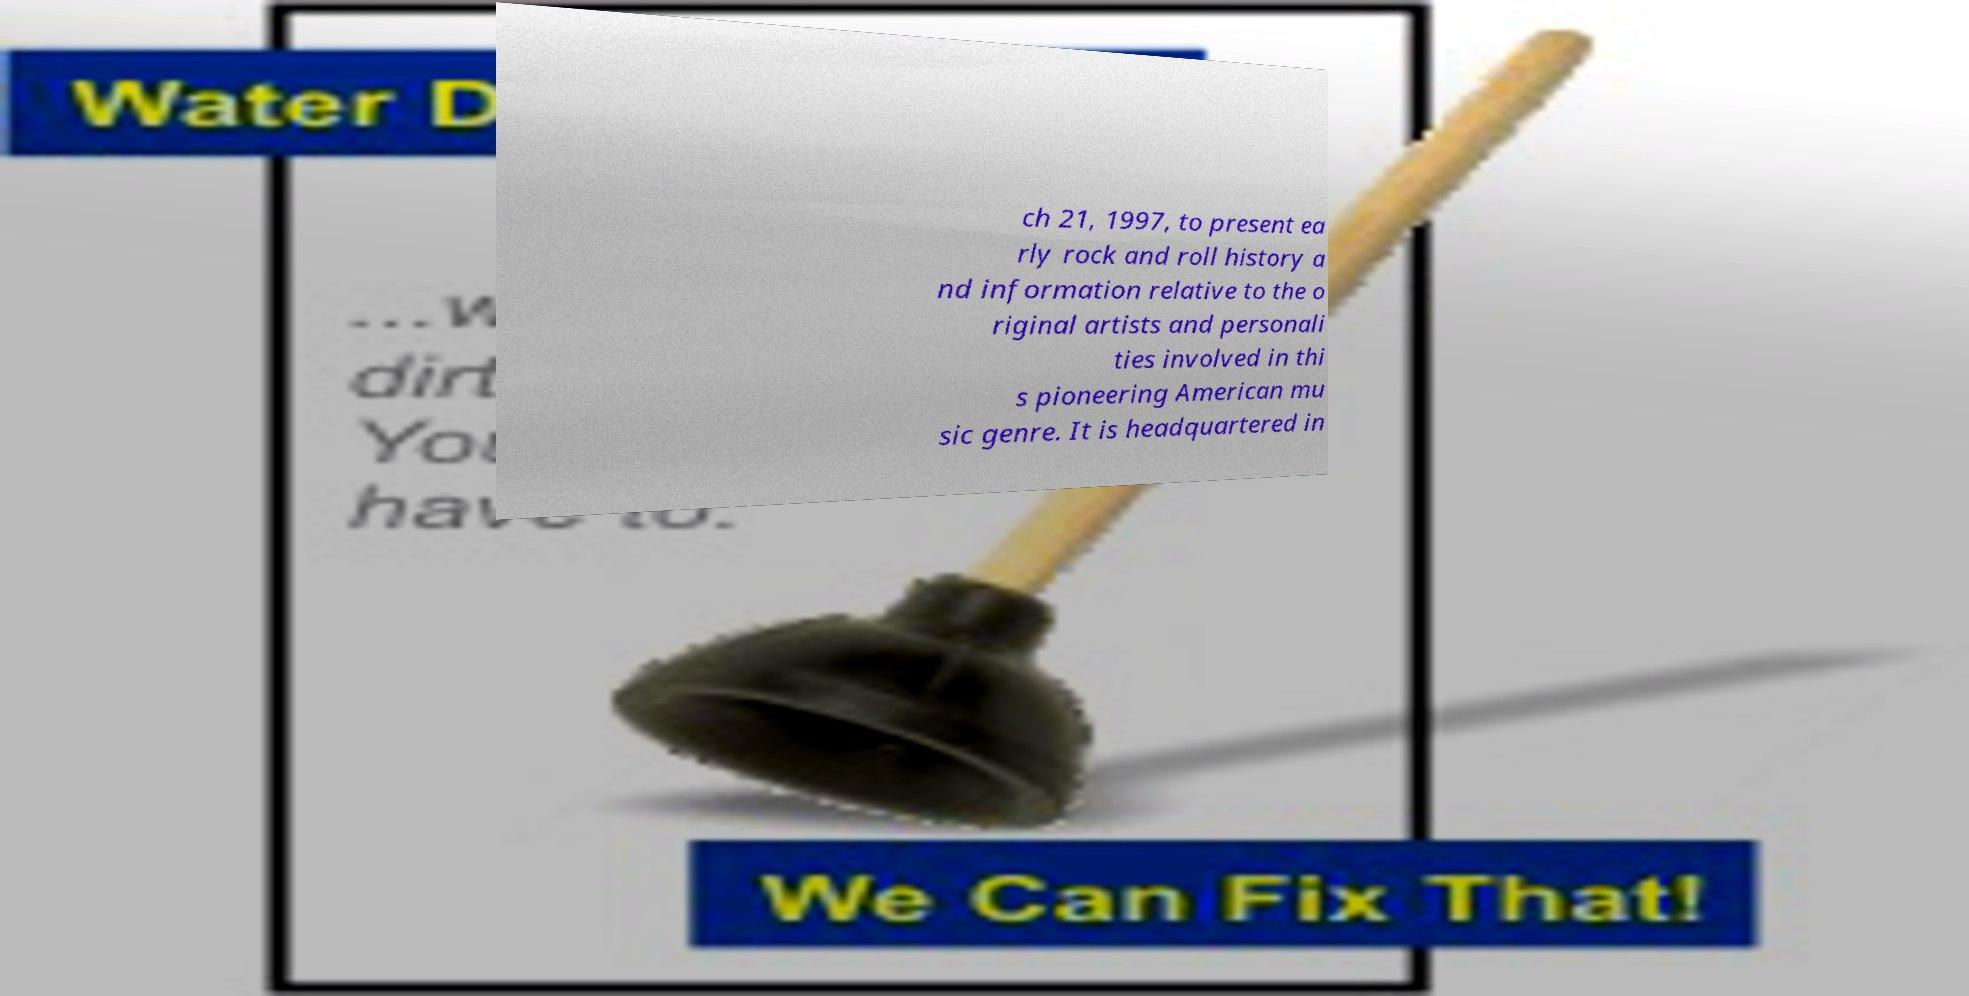Please read and relay the text visible in this image. What does it say? ch 21, 1997, to present ea rly rock and roll history a nd information relative to the o riginal artists and personali ties involved in thi s pioneering American mu sic genre. It is headquartered in 